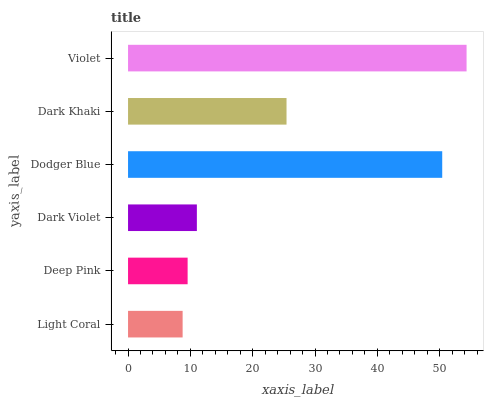Is Light Coral the minimum?
Answer yes or no. Yes. Is Violet the maximum?
Answer yes or no. Yes. Is Deep Pink the minimum?
Answer yes or no. No. Is Deep Pink the maximum?
Answer yes or no. No. Is Deep Pink greater than Light Coral?
Answer yes or no. Yes. Is Light Coral less than Deep Pink?
Answer yes or no. Yes. Is Light Coral greater than Deep Pink?
Answer yes or no. No. Is Deep Pink less than Light Coral?
Answer yes or no. No. Is Dark Khaki the high median?
Answer yes or no. Yes. Is Dark Violet the low median?
Answer yes or no. Yes. Is Dodger Blue the high median?
Answer yes or no. No. Is Dodger Blue the low median?
Answer yes or no. No. 